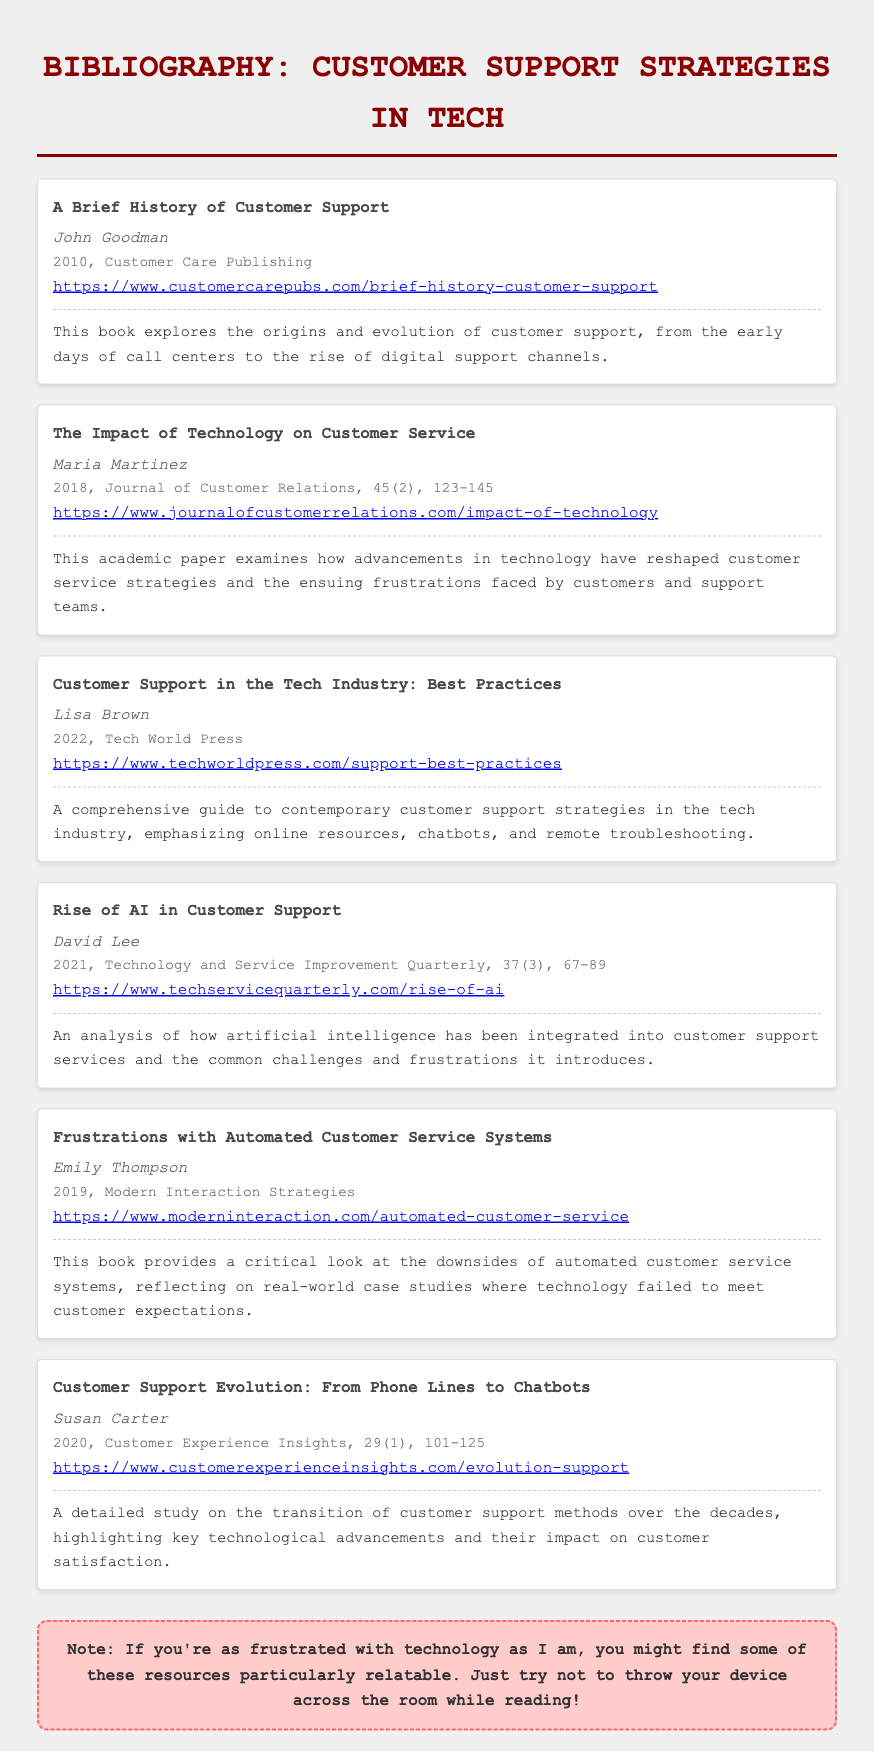What is the title of the first bibliography item? The title of the first bibliography item is "A Brief History of Customer Support."
Answer: A Brief History of Customer Support Who is the author of the second item? The author of the second item is Maria Martinez.
Answer: Maria Martinez In what year was "Frustrations with Automated Customer Service Systems" published? "Frustrations with Automated Customer Service Systems" was published in 2019.
Answer: 2019 How many items discuss the impact of technology on customer support? There are three items that discuss the impact of technology on customer support.
Answer: Three What is the main focus of "Rise of AI in Customer Support"? The main focus of "Rise of AI in Customer Support" is the integration of artificial intelligence into customer support services.
Answer: Integration of artificial intelligence into customer support services Which bibliography item examines real-world case studies? The item that examines real-world case studies is "Frustrations with Automated Customer Service Systems."
Answer: Frustrations with Automated Customer Service Systems In which publication was "Customer Support Evolution: From Phone Lines to Chatbots" featured? "Customer Support Evolution: From Phone Lines to Chatbots" was featured in Customer Experience Insights.
Answer: Customer Experience Insights What type of resource does "Customer Support in the Tech Industry: Best Practices" emphasize? "Customer Support in the Tech Industry: Best Practices" emphasizes online resources.
Answer: Online resources 